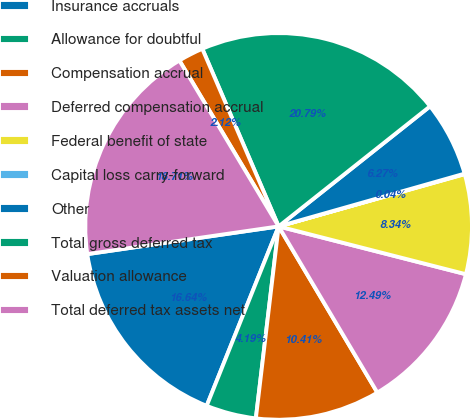Convert chart. <chart><loc_0><loc_0><loc_500><loc_500><pie_chart><fcel>Insurance accruals<fcel>Allowance for doubtful<fcel>Compensation accrual<fcel>Deferred compensation accrual<fcel>Federal benefit of state<fcel>Capital loss carry-forward<fcel>Other<fcel>Total gross deferred tax<fcel>Valuation allowance<fcel>Total deferred tax assets net<nl><fcel>16.64%<fcel>4.19%<fcel>10.41%<fcel>12.49%<fcel>8.34%<fcel>0.04%<fcel>6.27%<fcel>20.79%<fcel>2.12%<fcel>18.71%<nl></chart> 